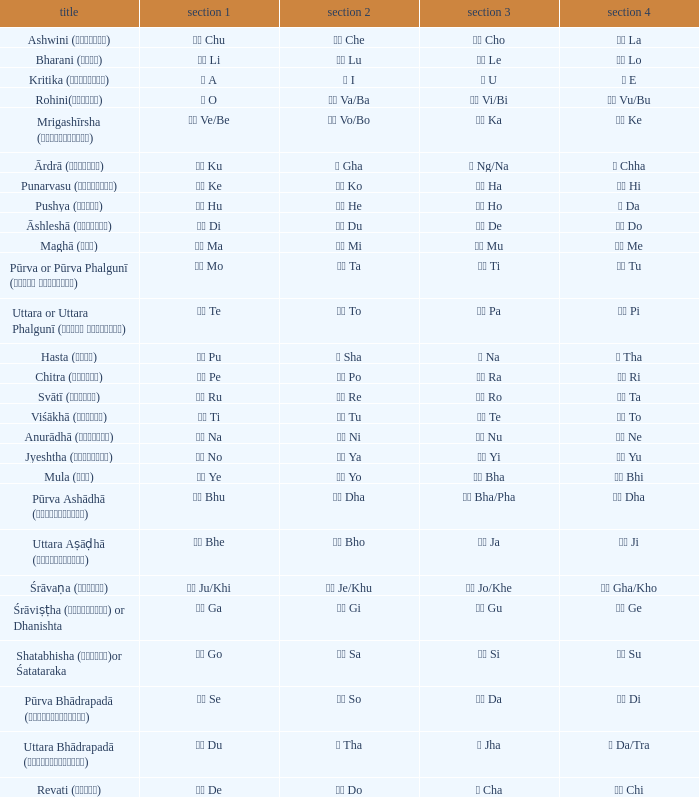Which Pada 3 has a Pada 1 of टे te? पा Pa. 